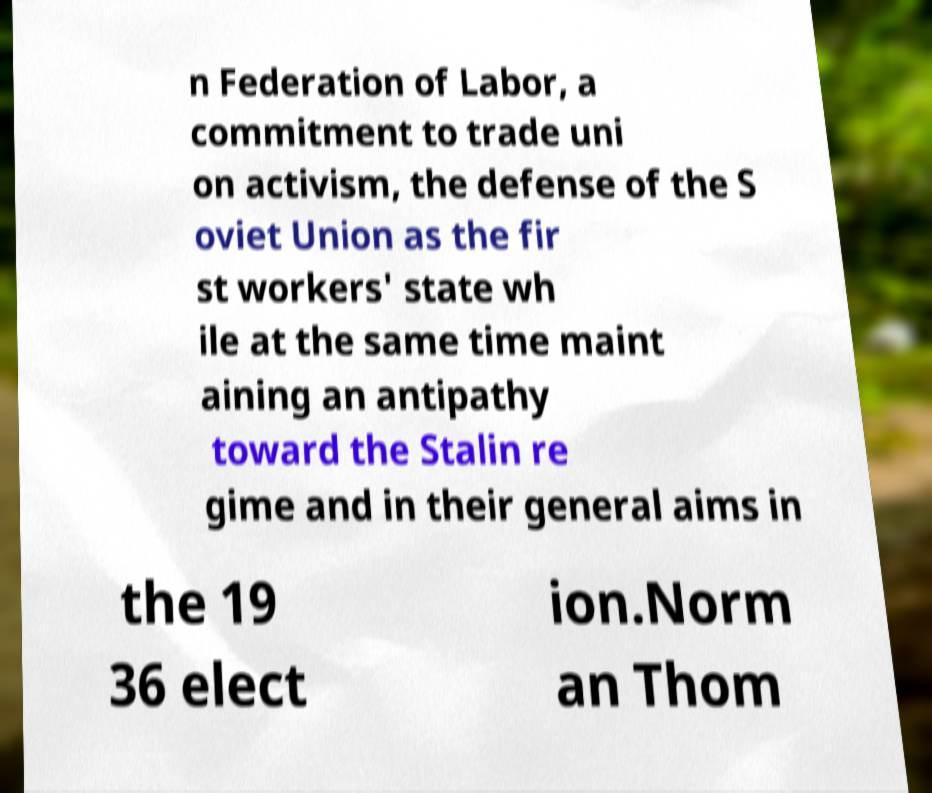What messages or text are displayed in this image? I need them in a readable, typed format. n Federation of Labor, a commitment to trade uni on activism, the defense of the S oviet Union as the fir st workers' state wh ile at the same time maint aining an antipathy toward the Stalin re gime and in their general aims in the 19 36 elect ion.Norm an Thom 